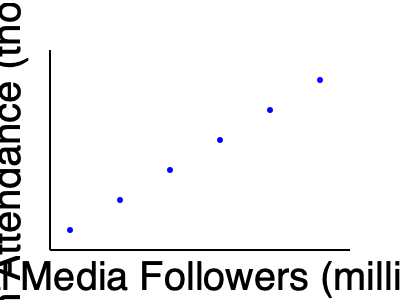Based on the scatter plot showing the relationship between a sports team's social media followers and stadium attendance, what type of correlation is observed, and how might this inform strategies for increasing fan engagement? To analyze the correlation between social media followers and stadium attendance:

1. Observe the pattern: The points form a clear trend from the bottom-left to the top-right of the graph.

2. Identify the correlation type:
   - As social media followers increase (x-axis), stadium attendance also increases (y-axis).
   - This indicates a positive correlation.

3. Assess the strength:
   - The points closely follow a linear pattern with little scatter.
   - This suggests a strong positive correlation.

4. Calculate the correlation coefficient:
   - While not given, it would likely be close to +1, confirming a strong positive correlation.

5. Interpret for fan engagement:
   - The strong positive correlation suggests that increased social media presence is associated with higher stadium attendance.
   - This implies that social media engagement could be an effective strategy for boosting in-person attendance.

6. Consider potential strategies:
   - Increase social media content and interaction to potentially drive stadium attendance.
   - Use social media for promotions, behind-the-scenes content, and real-time updates to enhance fan experience and engagement.
   - Integrate social media activities with in-stadium experiences to create a cohesive fan engagement strategy.

7. Note limitations:
   - Correlation does not imply causation. Other factors may influence both variables.
   - The relationship may vary for different teams, sports, or regions.
Answer: Strong positive correlation; suggests leveraging social media could potentially increase stadium attendance and overall fan engagement. 